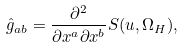Convert formula to latex. <formula><loc_0><loc_0><loc_500><loc_500>\hat { g } _ { a b } = \frac { \partial ^ { 2 } } { \partial x ^ { a } \partial x ^ { b } } S ( u , \Omega _ { H } ) ,</formula> 